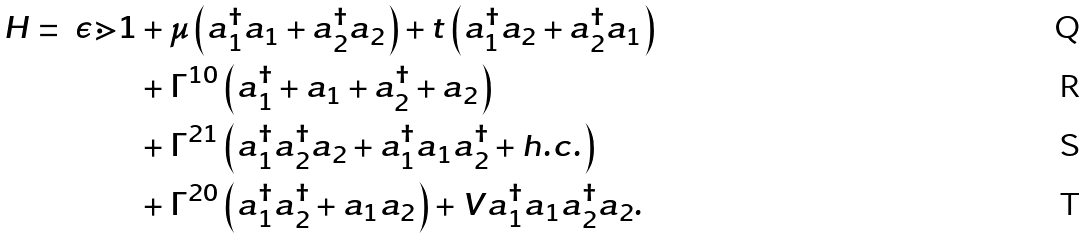<formula> <loc_0><loc_0><loc_500><loc_500>H = \ \epsilon \mathbb { m } { 1 } & + \mu \left ( a _ { 1 } ^ { \dagger } a _ { 1 } + a _ { 2 } ^ { \dagger } a _ { 2 } \right ) + t \left ( a _ { 1 } ^ { \dagger } a _ { 2 } + a _ { 2 } ^ { \dagger } a _ { 1 } \right ) \\ & + \Gamma ^ { 1 0 } \left ( a _ { 1 } ^ { \dagger } + a _ { 1 } + a _ { 2 } ^ { \dagger } + a _ { 2 } \right ) \\ & + \Gamma ^ { 2 1 } \left ( a _ { 1 } ^ { \dagger } a _ { 2 } ^ { \dagger } a _ { 2 } + a _ { 1 } ^ { \dagger } a _ { 1 } a _ { 2 } ^ { \dagger } + h . c . \right ) \\ & + \Gamma ^ { 2 0 } \left ( a _ { 1 } ^ { \dagger } a _ { 2 } ^ { \dagger } + a _ { 1 } a _ { 2 } \right ) + V a _ { 1 } ^ { \dagger } a _ { 1 } a _ { 2 } ^ { \dagger } a _ { 2 } .</formula> 